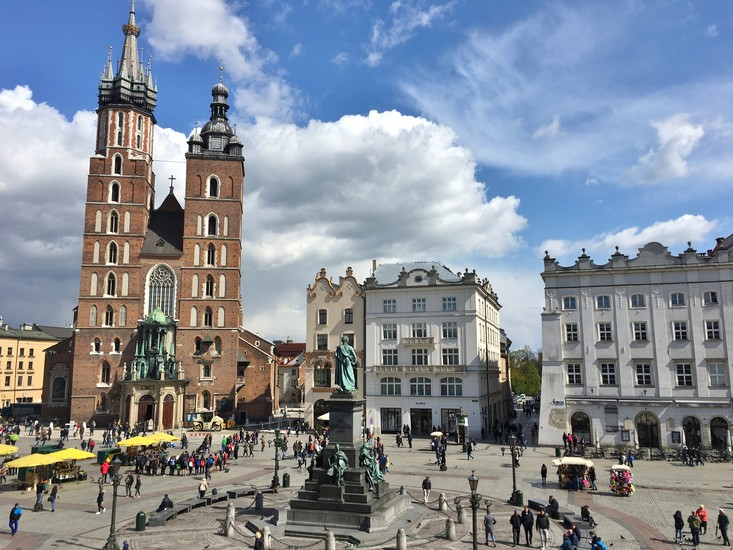Who is Adam Mickiewicz and why is his statue prominently placed in the square? Adam Mickiewicz was a revered Polish poet, dramatist, and national figure, often considered one of the greatest poets in Polish literature. Born in 1798, his works embody the spirit and struggles of the Polish nation during the 19th century, a time when Poland faced partitions and foreign dominance.

His most notable work, 'Pan Tadeusz,' is an epic poem that remains a cornerstone of Polish literary heritage. Mickiewicz's themes of patriotism, freedom, and resilience deeply resonated with the Polish people, earning him a place in their cultural heart.

The statue of Adam Mickiewicz in Krakow's Main Market Square, unveiled in 1898, commemorates his centenary and symbolizes national pride, reflecting his lasting influence on Polish identity and literature. It stands as a tribute to his contributions to Polish culture and his role as an inspirational figure in the country's quest for independence. 